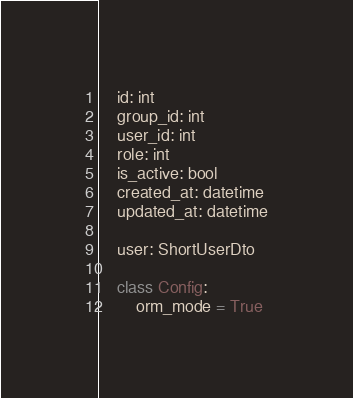Convert code to text. <code><loc_0><loc_0><loc_500><loc_500><_Python_>    id: int
    group_id: int
    user_id: int
    role: int
    is_active: bool
    created_at: datetime
    updated_at: datetime

    user: ShortUserDto

    class Config:
        orm_mode = True
</code> 